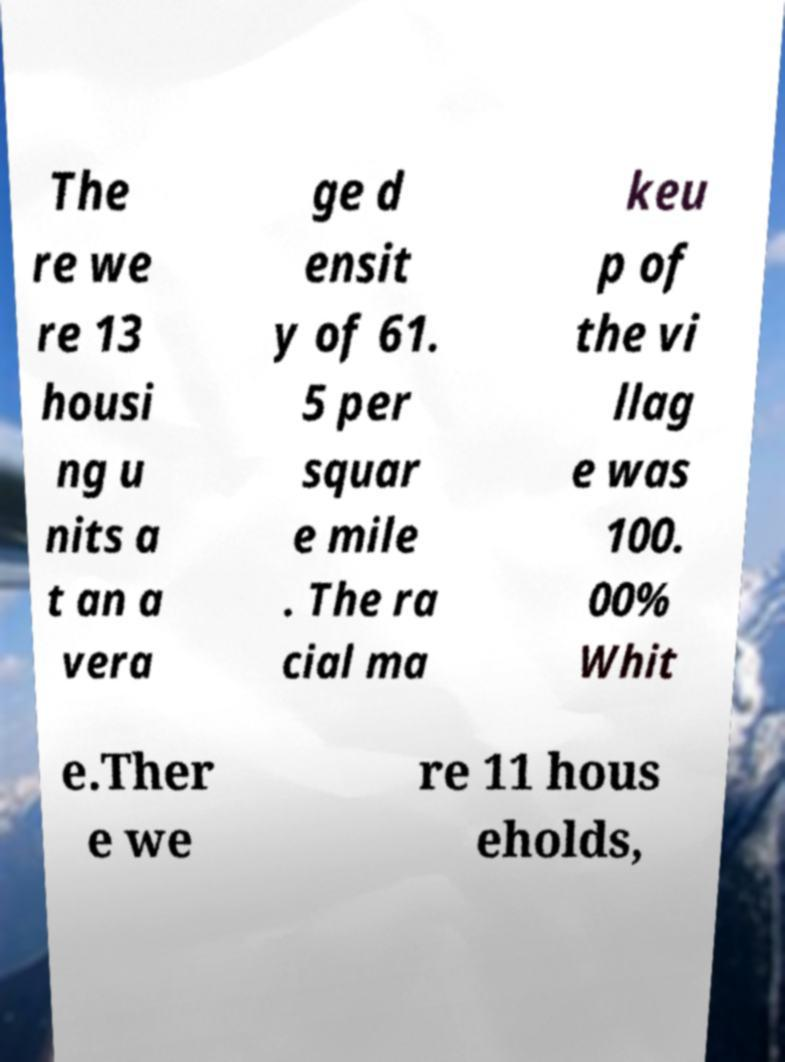Could you assist in decoding the text presented in this image and type it out clearly? The re we re 13 housi ng u nits a t an a vera ge d ensit y of 61. 5 per squar e mile . The ra cial ma keu p of the vi llag e was 100. 00% Whit e.Ther e we re 11 hous eholds, 